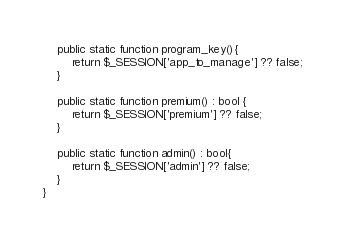<code> <loc_0><loc_0><loc_500><loc_500><_PHP_>
    public static function program_key(){
        return $_SESSION['app_to_manage'] ?? false;
    }

    public static function premium() : bool {
        return $_SESSION['premium'] ?? false;
    }

    public static function admin() : bool{
        return $_SESSION['admin'] ?? false;
    }
}
</code> 